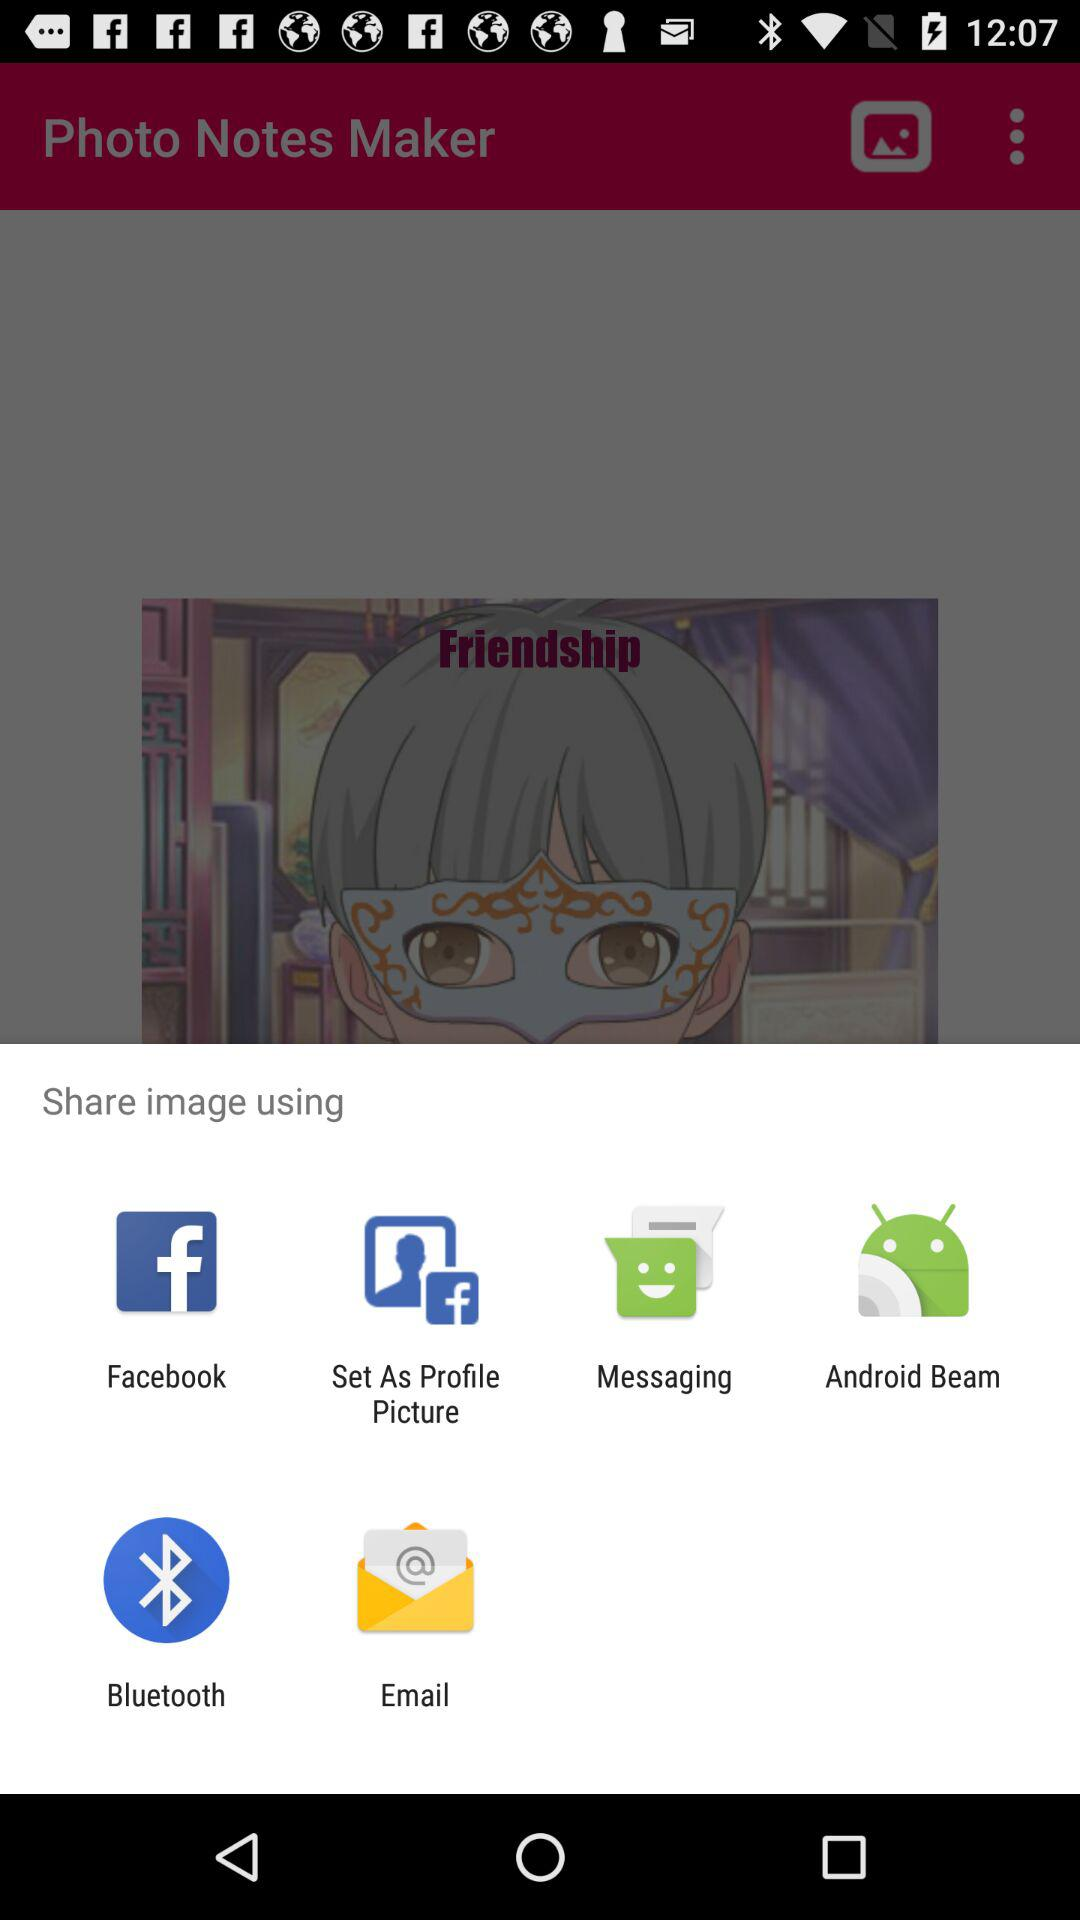Through which applications can we share the image? You can share the image through "Facebook", "Messaging", "Android Beam", "Bluetooth" and "Email". 